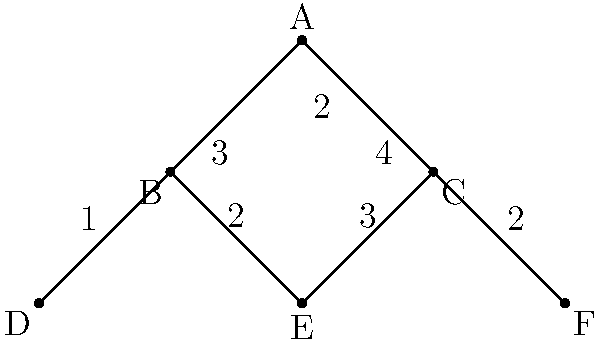Your latest TikTok video has gone viral, and you want to calculate its potential reach using the network diagram above. Each node represents a person, and the edges show connections between people. The numbers on the edges indicate how many times the content was shared between connected individuals. If the video starts from you (node A), what is the total number of times the content was shared across the entire network? To calculate the total number of times the content was shared, we need to sum up all the edge values in the network diagram. Let's break it down step-by-step:

1. From node A to B: 3 shares
2. From node A to C: 2 shares
3. From node B to D: 1 share
4. From node B to E: 2 shares
5. From node C to E: 3 shares
6. From node C to F: 2 shares

Now, let's sum up all these shares:

$$ \text{Total shares} = 3 + 2 + 1 + 2 + 3 + 2 = 13 $$

Therefore, the content was shared a total of 13 times across the entire network.
Answer: 13 